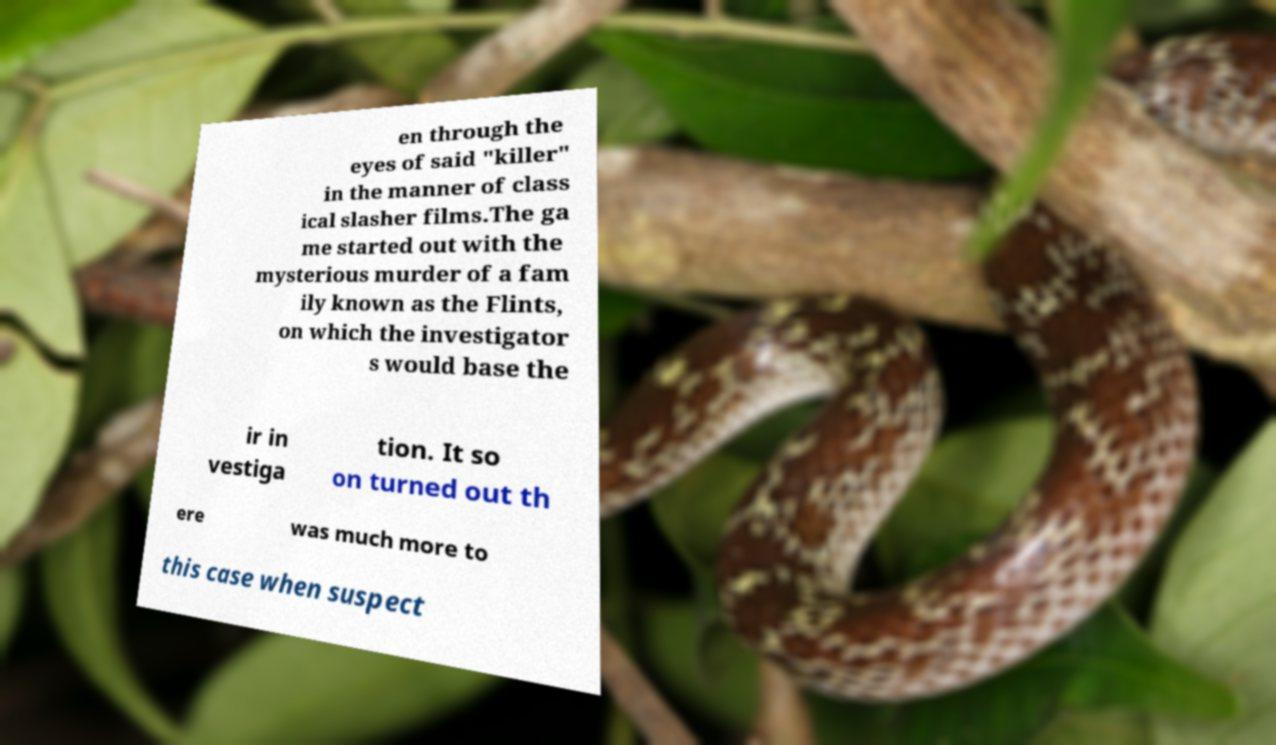Please identify and transcribe the text found in this image. en through the eyes of said "killer" in the manner of class ical slasher films.The ga me started out with the mysterious murder of a fam ily known as the Flints, on which the investigator s would base the ir in vestiga tion. It so on turned out th ere was much more to this case when suspect 